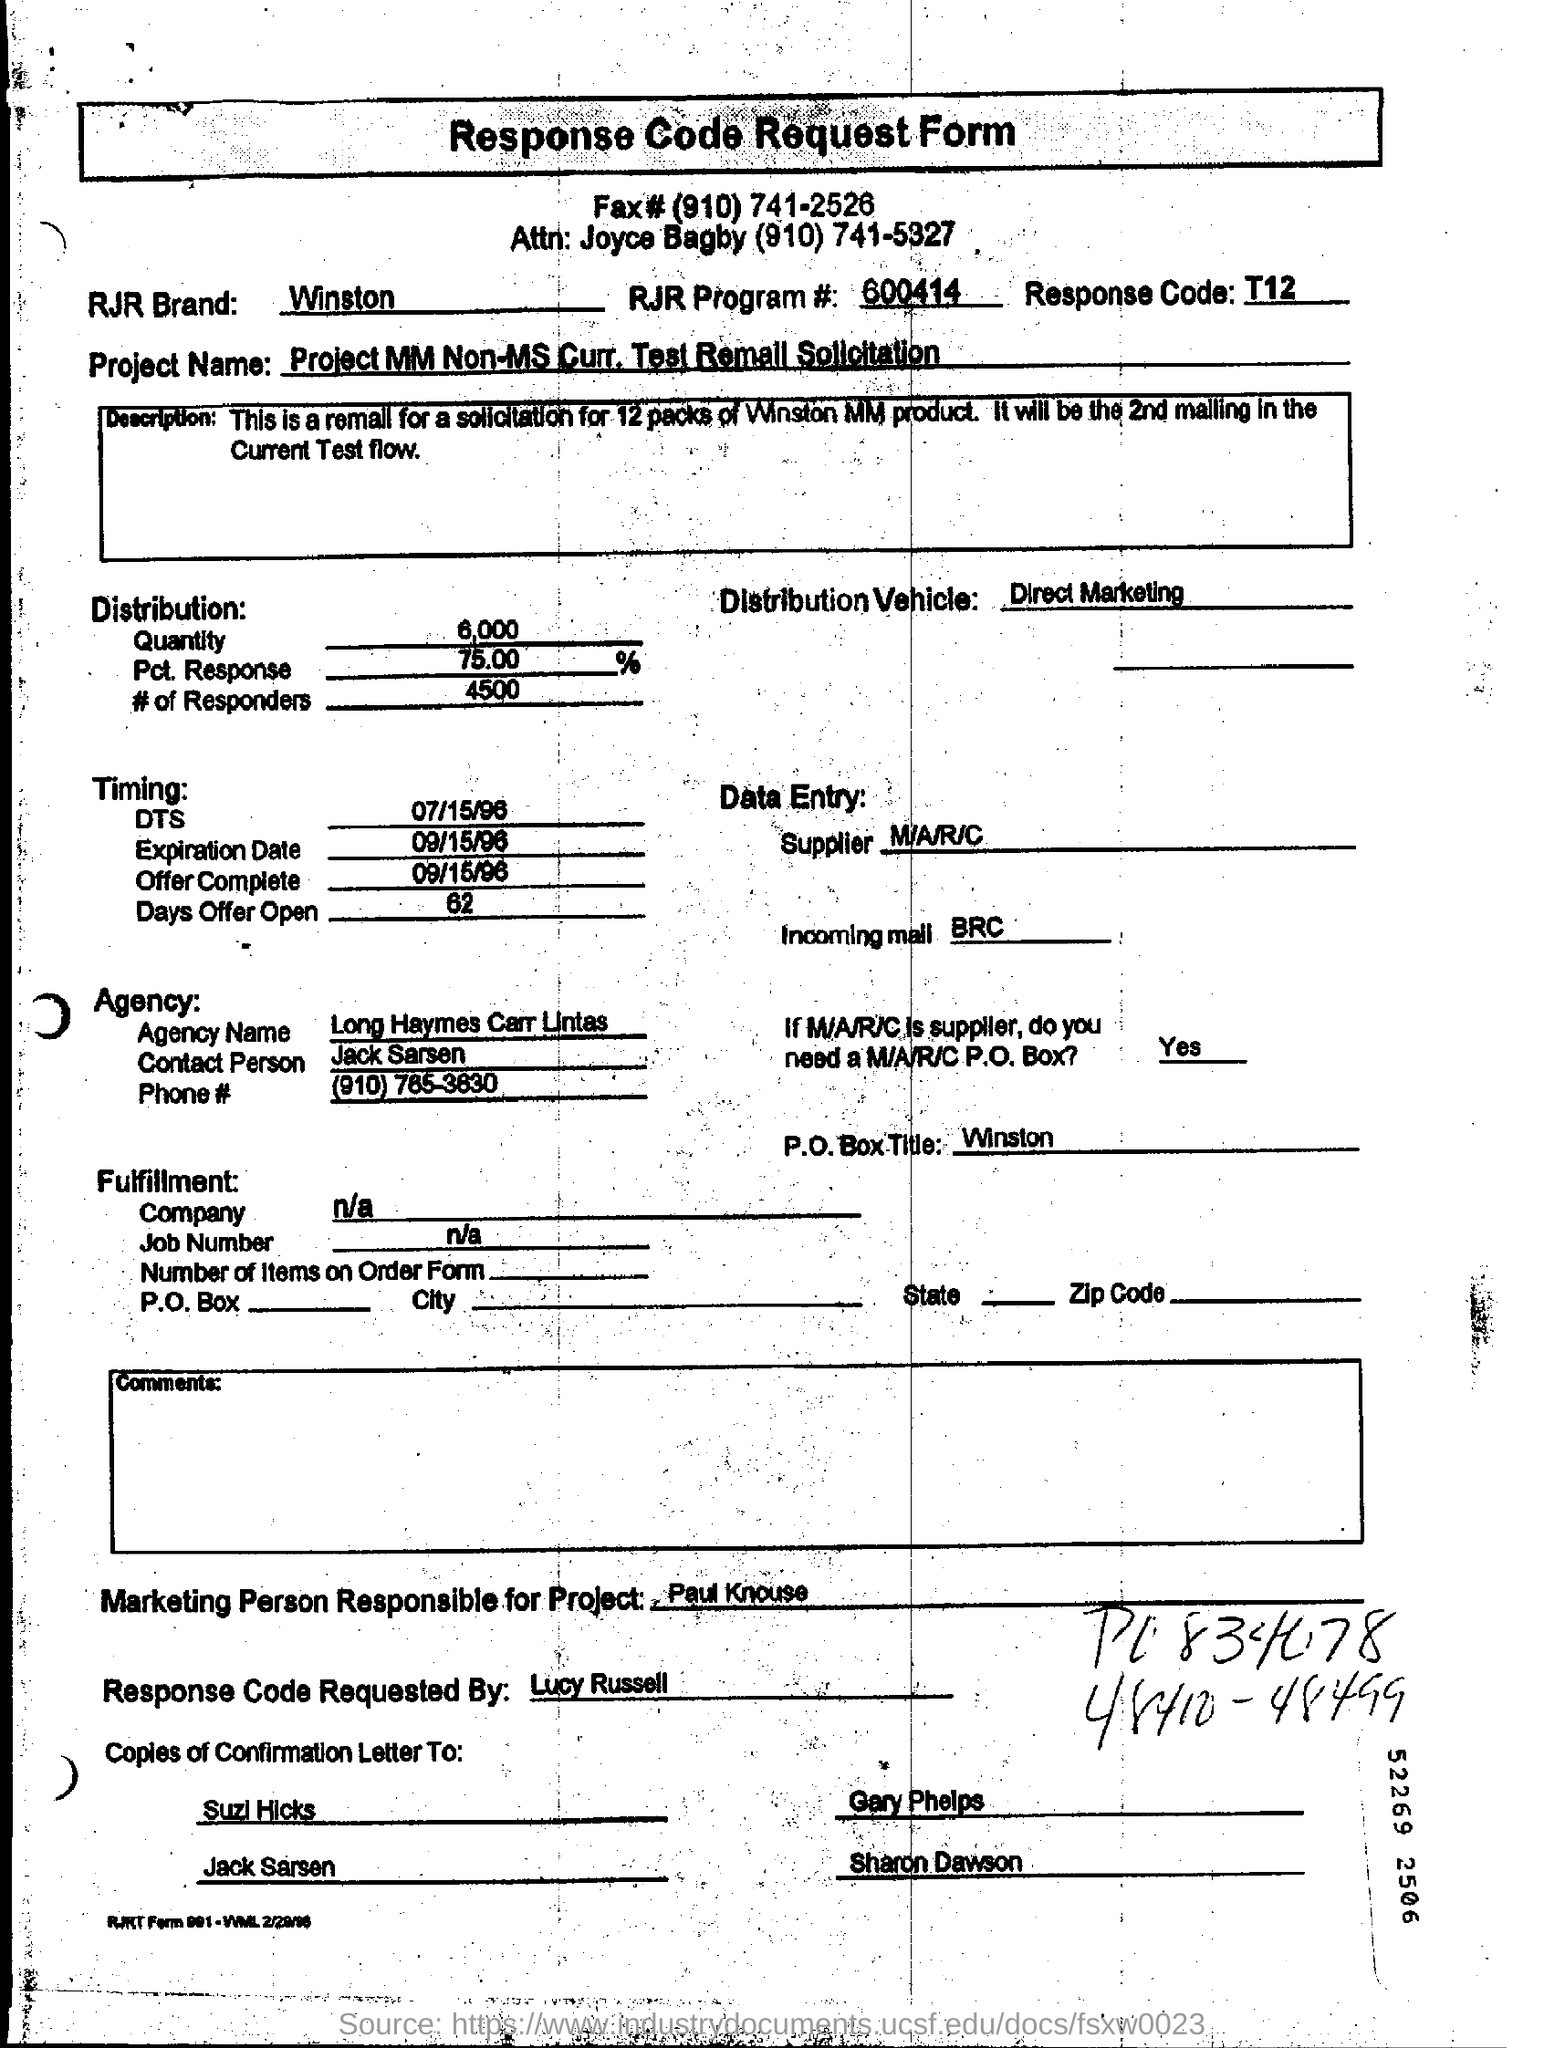What is the name of project?
Give a very brief answer. Project mm non-ms curr. test remail solicitation. Who are the contact person for the agency?
Offer a terse response. Jack Sarsen. What is the name of agency ?
Make the answer very short. Long Haymes Carr Lintas. 